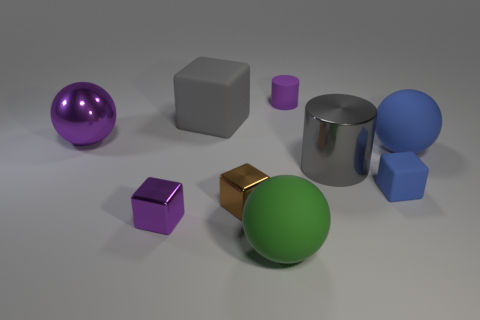Subtract all purple shiny blocks. How many blocks are left? 3 Subtract all gray cylinders. How many cylinders are left? 1 Subtract 2 blocks. How many blocks are left? 2 Subtract 0 red blocks. How many objects are left? 9 Subtract all balls. How many objects are left? 6 Subtract all gray cylinders. Subtract all blue spheres. How many cylinders are left? 1 Subtract all blue cylinders. Subtract all purple metallic cubes. How many objects are left? 8 Add 7 small purple matte objects. How many small purple matte objects are left? 8 Add 7 small purple metal objects. How many small purple metal objects exist? 8 